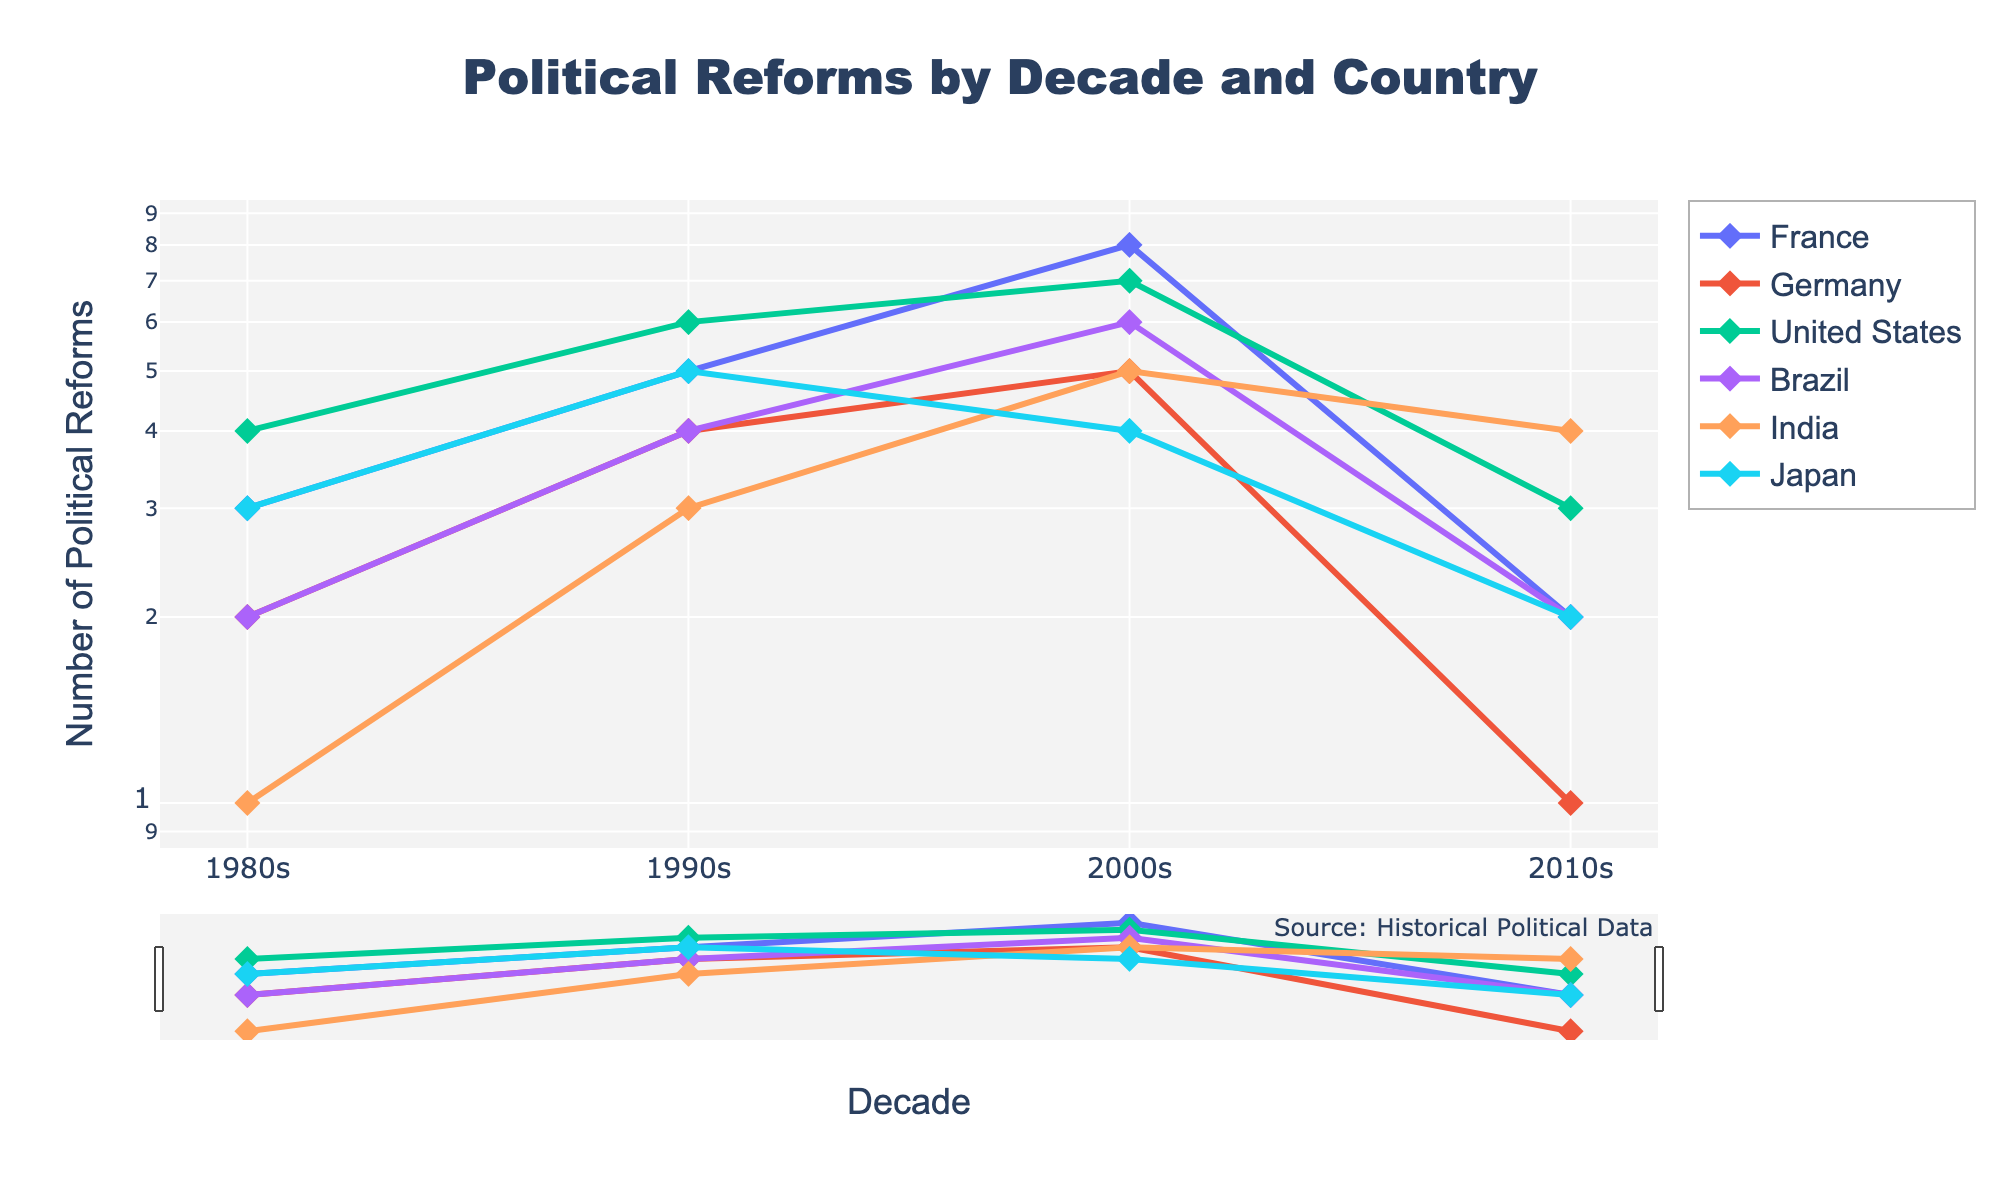how many political reforms were enacted in France in the 2000s? In the plot, look at the point representing the 2000s for France on the y-axis.
Answer: 8 Which country enacted the most political reforms in the 1990s? Compare the y-values for all countries in the 1990s.
Answer: United States How did the number of political reforms in Germany change from the 1980s to the 2010s? Observe the changes in the plotted line for Germany over these decades.
Answer: Decreased What is the sum of political reforms enacted by India in the 2000s and 2010s? Add the y-values for India in the 2000s and 2010s.
Answer: 9 Which country had the least number of political reforms in the 2010s? Find the country with the lowest point on the y-axis in the 2010s.
Answer: Germany How does the number of political reforms in the 2000s compare between France and Japan? Compare the y-values for France and Japan in the 2000s.
Answer: France had more Which country saw the greatest decrease in political reforms between any two consecutive decades? Calculate the differences in y-values for each country between consecutive decades and identify the largest drop.
Answer: France (2000s to 2010s) In which decade did Brazil see a twofold increase in political reforms compared to the previous decade? Identify the decade where Brazil's y-value approximately doubled compared to the previous decade.
Answer: 1990s How does the trend of political reforms in Japan differ from that of Brazil? Compare the trend lines for Japan and Brazil across the decades.
Answer: Japan's reforms fluctuated, while Brazil's generally increased before dropping 